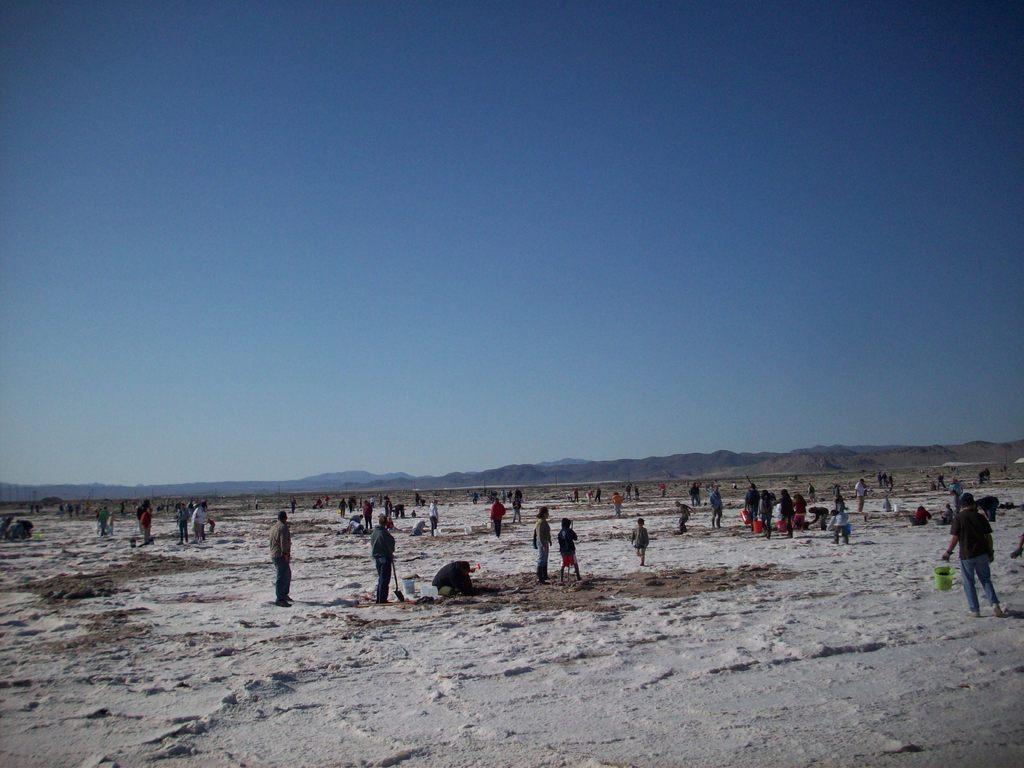Please provide a concise description of this image. At the bottom we can see few persons are standing on the ground and among them few are in squat position and few are holding buckets in their hands. In the background we can see mountains and sky 